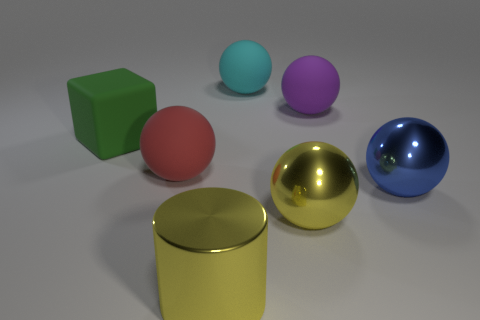Does the big rubber block have the same color as the large metal cylinder?
Give a very brief answer. No. What size is the red thing?
Your response must be concise. Large. How many large objects are the same color as the large matte cube?
Your answer should be compact. 0. There is a yellow object that is to the left of the big metallic sphere in front of the big blue ball; is there a big rubber object that is in front of it?
Your answer should be compact. No. What shape is the green rubber object that is the same size as the cyan ball?
Your answer should be very brief. Cube. What number of tiny things are cyan metallic balls or purple matte balls?
Keep it short and to the point. 0. What color is the block that is the same material as the big purple sphere?
Your answer should be compact. Green. Does the yellow shiny thing that is behind the metal cylinder have the same shape as the rubber object that is in front of the cube?
Your answer should be very brief. Yes. How many rubber objects are either tiny purple balls or blue things?
Offer a very short reply. 0. Is there any other thing that is the same shape as the large green rubber thing?
Offer a very short reply. No. 